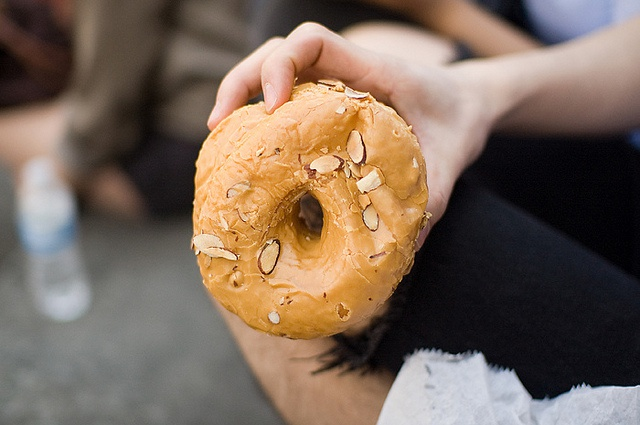Describe the objects in this image and their specific colors. I can see people in black, lightgray, and tan tones, donut in black, orange, tan, and olive tones, people in black, gray, and maroon tones, and bottle in black, darkgray, lightgray, and gray tones in this image. 